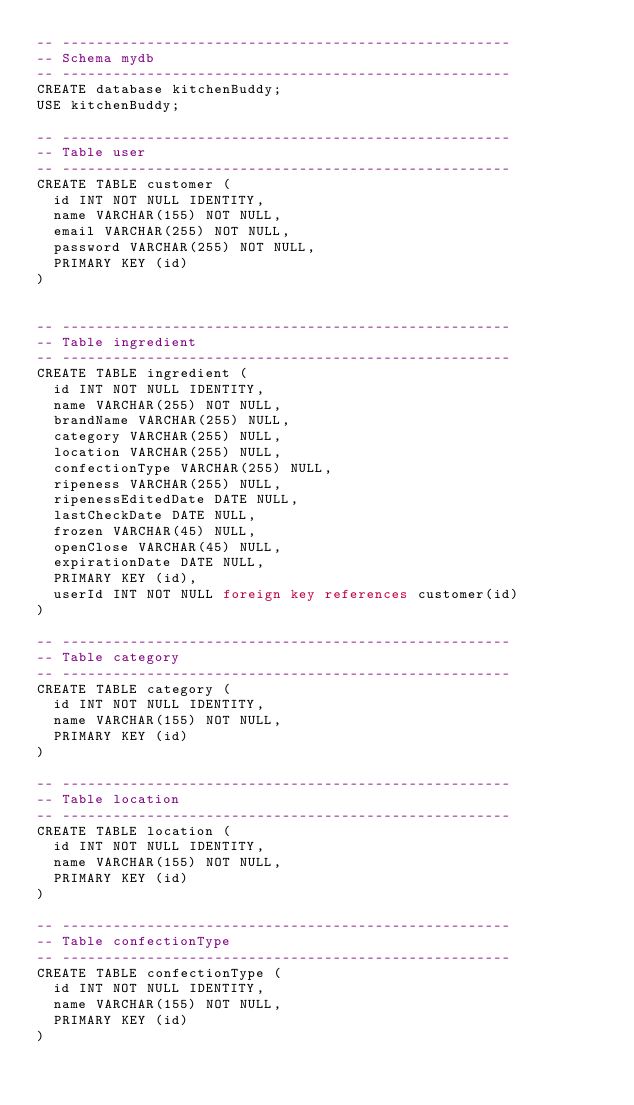<code> <loc_0><loc_0><loc_500><loc_500><_SQL_>-- -----------------------------------------------------
-- Schema mydb
-- -----------------------------------------------------
CREATE database kitchenBuddy;
USE kitchenBuddy;

-- -----------------------------------------------------
-- Table user
-- -----------------------------------------------------
CREATE TABLE customer (
  id INT NOT NULL IDENTITY,
  name VARCHAR(155) NOT NULL,
  email VARCHAR(255) NOT NULL,
  password VARCHAR(255) NOT NULL,
  PRIMARY KEY (id)
)


-- -----------------------------------------------------
-- Table ingredient
-- -----------------------------------------------------
CREATE TABLE ingredient (
  id INT NOT NULL IDENTITY,
  name VARCHAR(255) NOT NULL,
  brandName VARCHAR(255) NULL,
  category VARCHAR(255) NULL,
  location VARCHAR(255) NULL,
  confectionType VARCHAR(255) NULL,
  ripeness VARCHAR(255) NULL,
  ripenessEditedDate DATE NULL,
  lastCheckDate DATE NULL,
  frozen VARCHAR(45) NULL,
  openClose VARCHAR(45) NULL,
  expirationDate DATE NULL,
  PRIMARY KEY (id),
  userId INT NOT NULL foreign key references customer(id)
)

-- -----------------------------------------------------
-- Table category
-- -----------------------------------------------------
CREATE TABLE category (
  id INT NOT NULL IDENTITY,
  name VARCHAR(155) NOT NULL,
  PRIMARY KEY (id)
)

-- -----------------------------------------------------
-- Table location
-- -----------------------------------------------------
CREATE TABLE location (
  id INT NOT NULL IDENTITY,
  name VARCHAR(155) NOT NULL,
  PRIMARY KEY (id)
)

-- -----------------------------------------------------
-- Table confectionType
-- -----------------------------------------------------
CREATE TABLE confectionType (
  id INT NOT NULL IDENTITY,
  name VARCHAR(155) NOT NULL,
  PRIMARY KEY (id)
)

</code> 